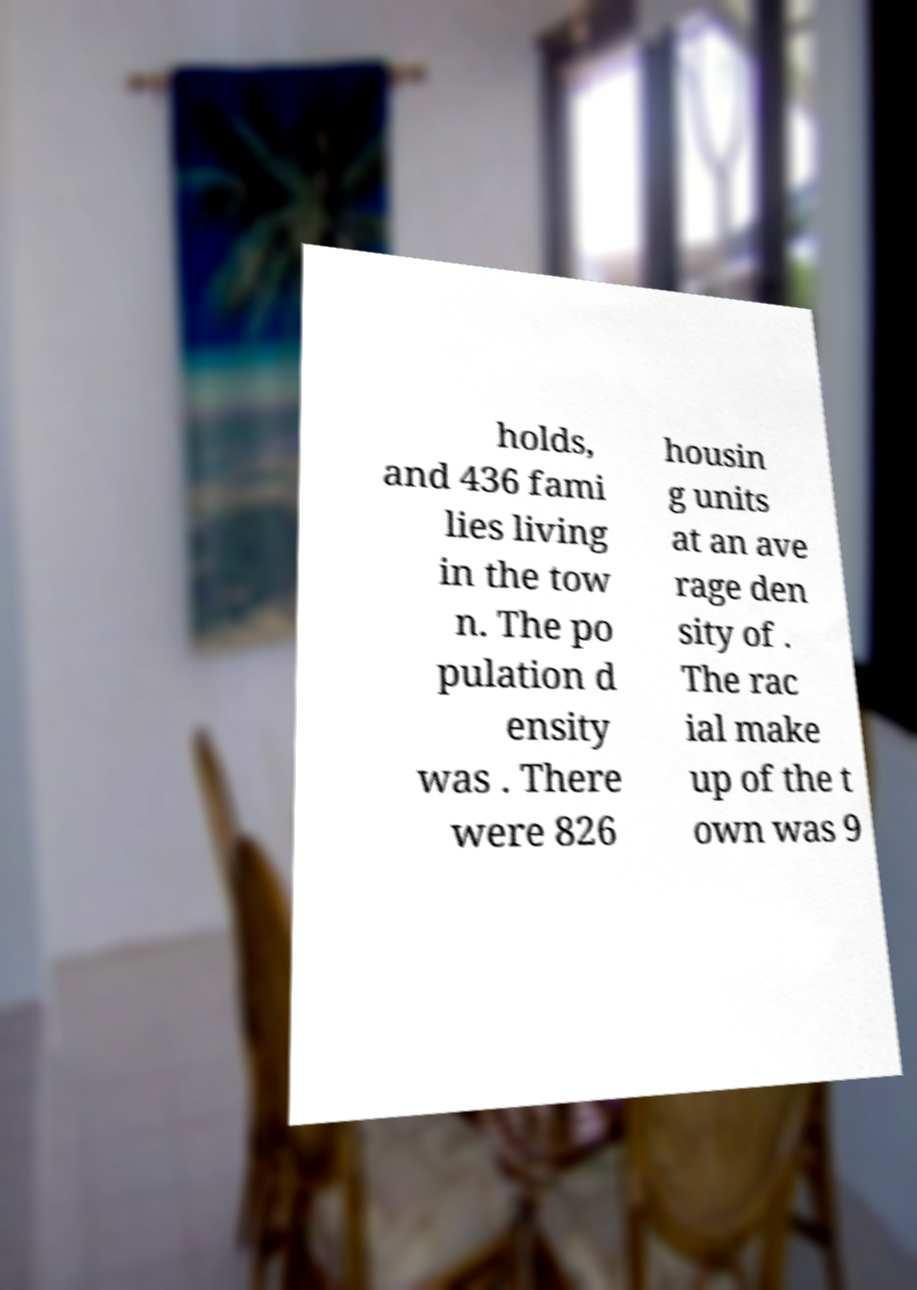I need the written content from this picture converted into text. Can you do that? holds, and 436 fami lies living in the tow n. The po pulation d ensity was . There were 826 housin g units at an ave rage den sity of . The rac ial make up of the t own was 9 